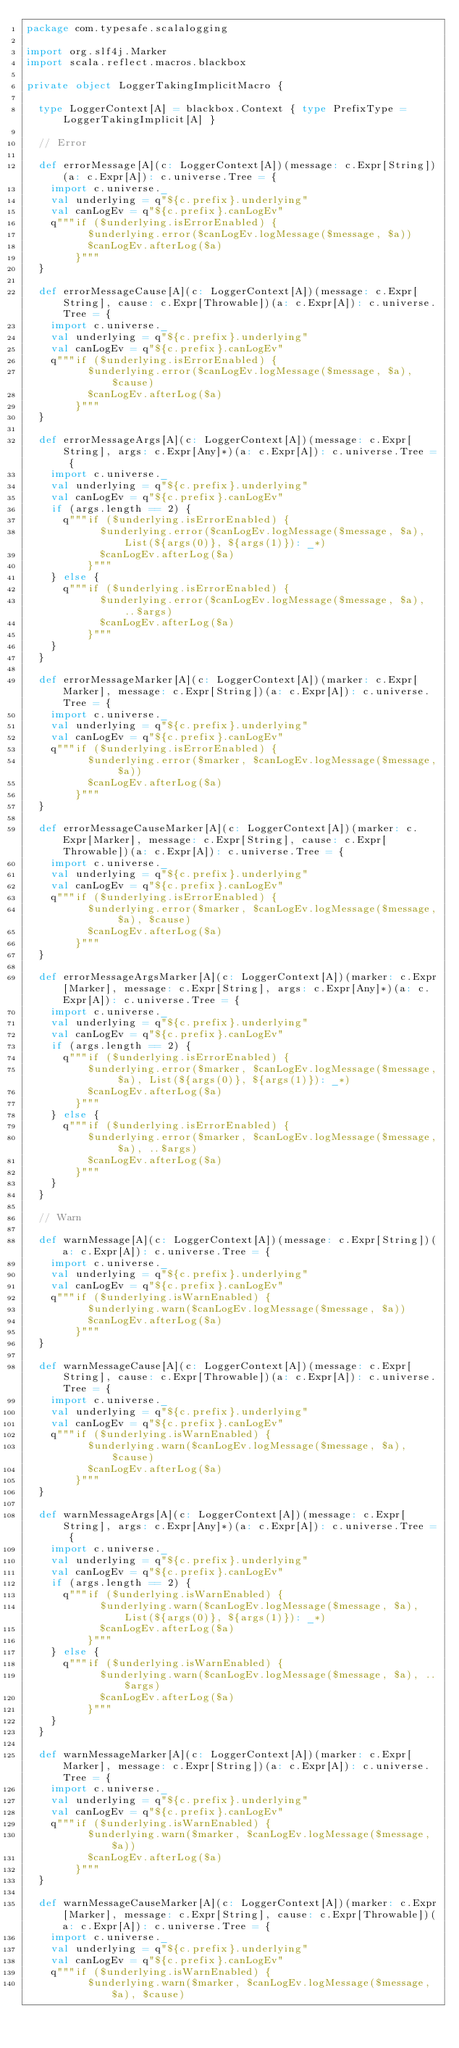<code> <loc_0><loc_0><loc_500><loc_500><_Scala_>package com.typesafe.scalalogging

import org.slf4j.Marker
import scala.reflect.macros.blackbox

private object LoggerTakingImplicitMacro {

  type LoggerContext[A] = blackbox.Context { type PrefixType = LoggerTakingImplicit[A] }

  // Error

  def errorMessage[A](c: LoggerContext[A])(message: c.Expr[String])(a: c.Expr[A]): c.universe.Tree = {
    import c.universe._
    val underlying = q"${c.prefix}.underlying"
    val canLogEv = q"${c.prefix}.canLogEv"
    q"""if ($underlying.isErrorEnabled) {
          $underlying.error($canLogEv.logMessage($message, $a))
          $canLogEv.afterLog($a)
        }"""
  }

  def errorMessageCause[A](c: LoggerContext[A])(message: c.Expr[String], cause: c.Expr[Throwable])(a: c.Expr[A]): c.universe.Tree = {
    import c.universe._
    val underlying = q"${c.prefix}.underlying"
    val canLogEv = q"${c.prefix}.canLogEv"
    q"""if ($underlying.isErrorEnabled) {
          $underlying.error($canLogEv.logMessage($message, $a), $cause)
          $canLogEv.afterLog($a)
        }"""
  }

  def errorMessageArgs[A](c: LoggerContext[A])(message: c.Expr[String], args: c.Expr[Any]*)(a: c.Expr[A]): c.universe.Tree = {
    import c.universe._
    val underlying = q"${c.prefix}.underlying"
    val canLogEv = q"${c.prefix}.canLogEv"
    if (args.length == 2) {
      q"""if ($underlying.isErrorEnabled) {
            $underlying.error($canLogEv.logMessage($message, $a), List(${args(0)}, ${args(1)}): _*)
            $canLogEv.afterLog($a)
          }"""
    } else {
      q"""if ($underlying.isErrorEnabled) {
            $underlying.error($canLogEv.logMessage($message, $a), ..$args)
            $canLogEv.afterLog($a)
          }"""
    }
  }

  def errorMessageMarker[A](c: LoggerContext[A])(marker: c.Expr[Marker], message: c.Expr[String])(a: c.Expr[A]): c.universe.Tree = {
    import c.universe._
    val underlying = q"${c.prefix}.underlying"
    val canLogEv = q"${c.prefix}.canLogEv"
    q"""if ($underlying.isErrorEnabled) {
          $underlying.error($marker, $canLogEv.logMessage($message, $a))
          $canLogEv.afterLog($a)
        }"""
  }

  def errorMessageCauseMarker[A](c: LoggerContext[A])(marker: c.Expr[Marker], message: c.Expr[String], cause: c.Expr[Throwable])(a: c.Expr[A]): c.universe.Tree = {
    import c.universe._
    val underlying = q"${c.prefix}.underlying"
    val canLogEv = q"${c.prefix}.canLogEv"
    q"""if ($underlying.isErrorEnabled) {
          $underlying.error($marker, $canLogEv.logMessage($message, $a), $cause)
          $canLogEv.afterLog($a)
        }"""
  }

  def errorMessageArgsMarker[A](c: LoggerContext[A])(marker: c.Expr[Marker], message: c.Expr[String], args: c.Expr[Any]*)(a: c.Expr[A]): c.universe.Tree = {
    import c.universe._
    val underlying = q"${c.prefix}.underlying"
    val canLogEv = q"${c.prefix}.canLogEv"
    if (args.length == 2) {
      q"""if ($underlying.isErrorEnabled) {
          $underlying.error($marker, $canLogEv.logMessage($message, $a), List(${args(0)}, ${args(1)}): _*)
          $canLogEv.afterLog($a)
        }"""
    } else {
      q"""if ($underlying.isErrorEnabled) {
          $underlying.error($marker, $canLogEv.logMessage($message, $a), ..$args)
          $canLogEv.afterLog($a)
        }"""
    }
  }

  // Warn

  def warnMessage[A](c: LoggerContext[A])(message: c.Expr[String])(a: c.Expr[A]): c.universe.Tree = {
    import c.universe._
    val underlying = q"${c.prefix}.underlying"
    val canLogEv = q"${c.prefix}.canLogEv"
    q"""if ($underlying.isWarnEnabled) {
          $underlying.warn($canLogEv.logMessage($message, $a))
          $canLogEv.afterLog($a)
        }"""
  }

  def warnMessageCause[A](c: LoggerContext[A])(message: c.Expr[String], cause: c.Expr[Throwable])(a: c.Expr[A]): c.universe.Tree = {
    import c.universe._
    val underlying = q"${c.prefix}.underlying"
    val canLogEv = q"${c.prefix}.canLogEv"
    q"""if ($underlying.isWarnEnabled) {
          $underlying.warn($canLogEv.logMessage($message, $a), $cause)
          $canLogEv.afterLog($a)
        }"""
  }

  def warnMessageArgs[A](c: LoggerContext[A])(message: c.Expr[String], args: c.Expr[Any]*)(a: c.Expr[A]): c.universe.Tree = {
    import c.universe._
    val underlying = q"${c.prefix}.underlying"
    val canLogEv = q"${c.prefix}.canLogEv"
    if (args.length == 2) {
      q"""if ($underlying.isWarnEnabled) {
            $underlying.warn($canLogEv.logMessage($message, $a), List(${args(0)}, ${args(1)}): _*)
            $canLogEv.afterLog($a)
          }"""
    } else {
      q"""if ($underlying.isWarnEnabled) {
            $underlying.warn($canLogEv.logMessage($message, $a), ..$args)
            $canLogEv.afterLog($a)
          }"""
    }
  }

  def warnMessageMarker[A](c: LoggerContext[A])(marker: c.Expr[Marker], message: c.Expr[String])(a: c.Expr[A]): c.universe.Tree = {
    import c.universe._
    val underlying = q"${c.prefix}.underlying"
    val canLogEv = q"${c.prefix}.canLogEv"
    q"""if ($underlying.isWarnEnabled) {
          $underlying.warn($marker, $canLogEv.logMessage($message, $a))
          $canLogEv.afterLog($a)
        }"""
  }

  def warnMessageCauseMarker[A](c: LoggerContext[A])(marker: c.Expr[Marker], message: c.Expr[String], cause: c.Expr[Throwable])(a: c.Expr[A]): c.universe.Tree = {
    import c.universe._
    val underlying = q"${c.prefix}.underlying"
    val canLogEv = q"${c.prefix}.canLogEv"
    q"""if ($underlying.isWarnEnabled) {
          $underlying.warn($marker, $canLogEv.logMessage($message, $a), $cause)</code> 